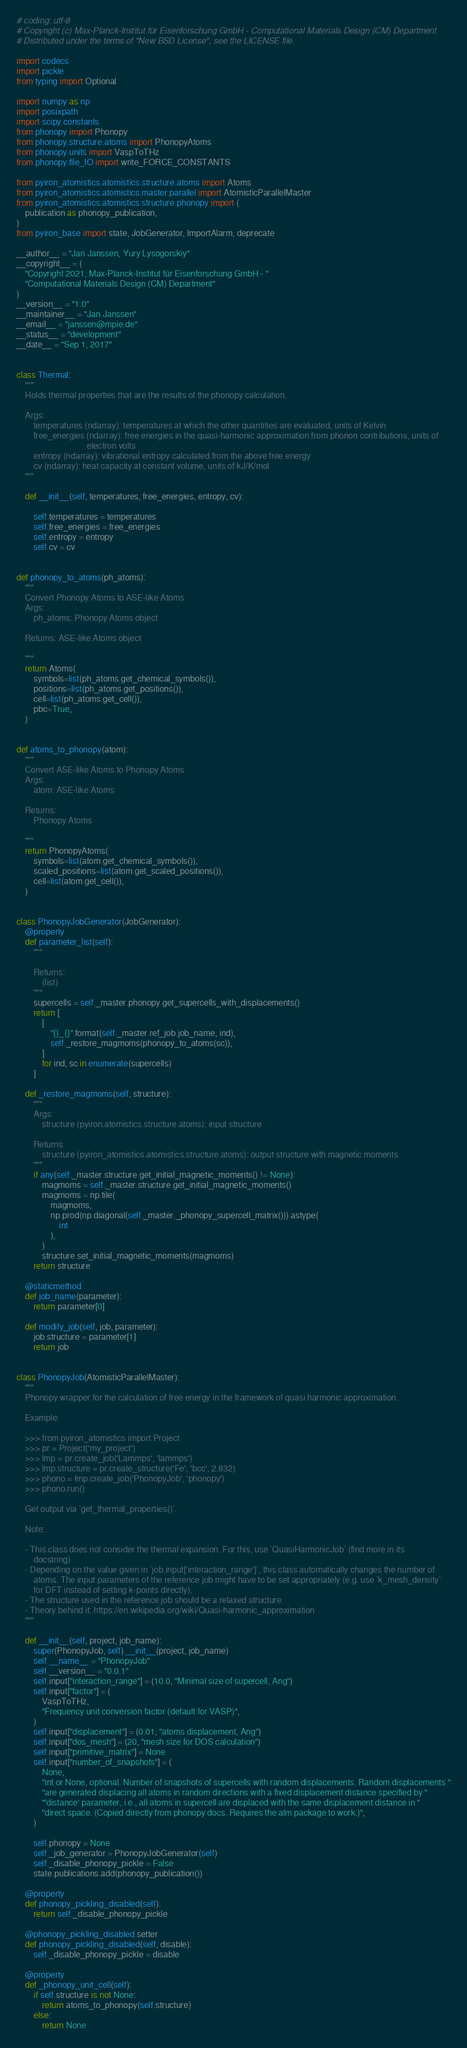Convert code to text. <code><loc_0><loc_0><loc_500><loc_500><_Python_># coding: utf-8
# Copyright (c) Max-Planck-Institut für Eisenforschung GmbH - Computational Materials Design (CM) Department
# Distributed under the terms of "New BSD License", see the LICENSE file.

import codecs
import pickle
from typing import Optional

import numpy as np
import posixpath
import scipy.constants
from phonopy import Phonopy
from phonopy.structure.atoms import PhonopyAtoms
from phonopy.units import VaspToTHz
from phonopy.file_IO import write_FORCE_CONSTANTS

from pyiron_atomistics.atomistics.structure.atoms import Atoms
from pyiron_atomistics.atomistics.master.parallel import AtomisticParallelMaster
from pyiron_atomistics.atomistics.structure.phonopy import (
    publication as phonopy_publication,
)
from pyiron_base import state, JobGenerator, ImportAlarm, deprecate

__author__ = "Jan Janssen, Yury Lysogorskiy"
__copyright__ = (
    "Copyright 2021, Max-Planck-Institut für Eisenforschung GmbH - "
    "Computational Materials Design (CM) Department"
)
__version__ = "1.0"
__maintainer__ = "Jan Janssen"
__email__ = "janssen@mpie.de"
__status__ = "development"
__date__ = "Sep 1, 2017"


class Thermal:
    """
    Holds thermal properties that are the results of the phonopy calculation.

    Args:
        temperatures (ndarray): temperatures at which the other quantities are evaluated, units of Kelvin
        free_energies (ndarray): free energies in the quasi-harmonic approximation from phonon contributions, units of
                                 electron volts
        entropy (ndarray): vibrational entropy calculated from the above free energy
        cv (ndarray): heat capacity at constant volume, units of kJ/K/mol
    """

    def __init__(self, temperatures, free_energies, entropy, cv):

        self.temperatures = temperatures
        self.free_energies = free_energies
        self.entropy = entropy
        self.cv = cv


def phonopy_to_atoms(ph_atoms):
    """
    Convert Phonopy Atoms to ASE-like Atoms
    Args:
        ph_atoms: Phonopy Atoms object

    Returns: ASE-like Atoms object

    """
    return Atoms(
        symbols=list(ph_atoms.get_chemical_symbols()),
        positions=list(ph_atoms.get_positions()),
        cell=list(ph_atoms.get_cell()),
        pbc=True,
    )


def atoms_to_phonopy(atom):
    """
    Convert ASE-like Atoms to Phonopy Atoms
    Args:
        atom: ASE-like Atoms

    Returns:
        Phonopy Atoms

    """
    return PhonopyAtoms(
        symbols=list(atom.get_chemical_symbols()),
        scaled_positions=list(atom.get_scaled_positions()),
        cell=list(atom.get_cell()),
    )


class PhonopyJobGenerator(JobGenerator):
    @property
    def parameter_list(self):
        """

        Returns:
            (list)
        """
        supercells = self._master.phonopy.get_supercells_with_displacements()
        return [
            [
                "{}_{}".format(self._master.ref_job.job_name, ind),
                self._restore_magmoms(phonopy_to_atoms(sc)),
            ]
            for ind, sc in enumerate(supercells)
        ]

    def _restore_magmoms(self, structure):
        """
        Args:
            structure (pyiron.atomistics.structure.atoms): input structure

        Returns:
            structure (pyiron_atomistics.atomistics.structure.atoms): output structure with magnetic moments
        """
        if any(self._master.structure.get_initial_magnetic_moments() != None):
            magmoms = self._master.structure.get_initial_magnetic_moments()
            magmoms = np.tile(
                magmoms,
                np.prod(np.diagonal(self._master._phonopy_supercell_matrix())).astype(
                    int
                ),
            )
            structure.set_initial_magnetic_moments(magmoms)
        return structure

    @staticmethod
    def job_name(parameter):
        return parameter[0]

    def modify_job(self, job, parameter):
        job.structure = parameter[1]
        return job


class PhonopyJob(AtomisticParallelMaster):
    """
    Phonopy wrapper for the calculation of free energy in the framework of quasi harmonic approximation.

    Example:

    >>> from pyiron_atomistics import Project
    >>> pr = Project('my_project')
    >>> lmp = pr.create_job('Lammps', 'lammps')
    >>> lmp.structure = pr.create_structure('Fe', 'bcc', 2.832)
    >>> phono = lmp.create_job('PhonopyJob', 'phonopy')
    >>> phono.run()

    Get output via `get_thermal_properties()`.

    Note:

    - This class does not consider the thermal expansion. For this, use `QuasiHarmonicJob` (find more in its
        docstring)
    - Depending on the value given in `job.input['interaction_range']`, this class automatically changes the number of
        atoms. The input parameters of the reference job might have to be set appropriately (e.g. use `k_mesh_density`
        for DFT instead of setting k-points directly).
    - The structure used in the reference job should be a relaxed structure.
    - Theory behind it: https://en.wikipedia.org/wiki/Quasi-harmonic_approximation
    """

    def __init__(self, project, job_name):
        super(PhonopyJob, self).__init__(project, job_name)
        self.__name__ = "PhonopyJob"
        self.__version__ = "0.0.1"
        self.input["interaction_range"] = (10.0, "Minimal size of supercell, Ang")
        self.input["factor"] = (
            VaspToTHz,
            "Frequency unit conversion factor (default for VASP)",
        )
        self.input["displacement"] = (0.01, "atoms displacement, Ang")
        self.input["dos_mesh"] = (20, "mesh size for DOS calculation")
        self.input["primitive_matrix"] = None
        self.input["number_of_snapshots"] = (
            None,
            "int or None, optional. Number of snapshots of supercells with random displacements. Random displacements "
            "are generated displacing all atoms in random directions with a fixed displacement distance specified by "
            "'distance' parameter, i.e., all atoms in supercell are displaced with the same displacement distance in "
            "direct space. (Copied directly from phonopy docs. Requires the alm package to work.)",
        )

        self.phonopy = None
        self._job_generator = PhonopyJobGenerator(self)
        self._disable_phonopy_pickle = False
        state.publications.add(phonopy_publication())

    @property
    def phonopy_pickling_disabled(self):
        return self._disable_phonopy_pickle

    @phonopy_pickling_disabled.setter
    def phonopy_pickling_disabled(self, disable):
        self._disable_phonopy_pickle = disable

    @property
    def _phonopy_unit_cell(self):
        if self.structure is not None:
            return atoms_to_phonopy(self.structure)
        else:
            return None
</code> 